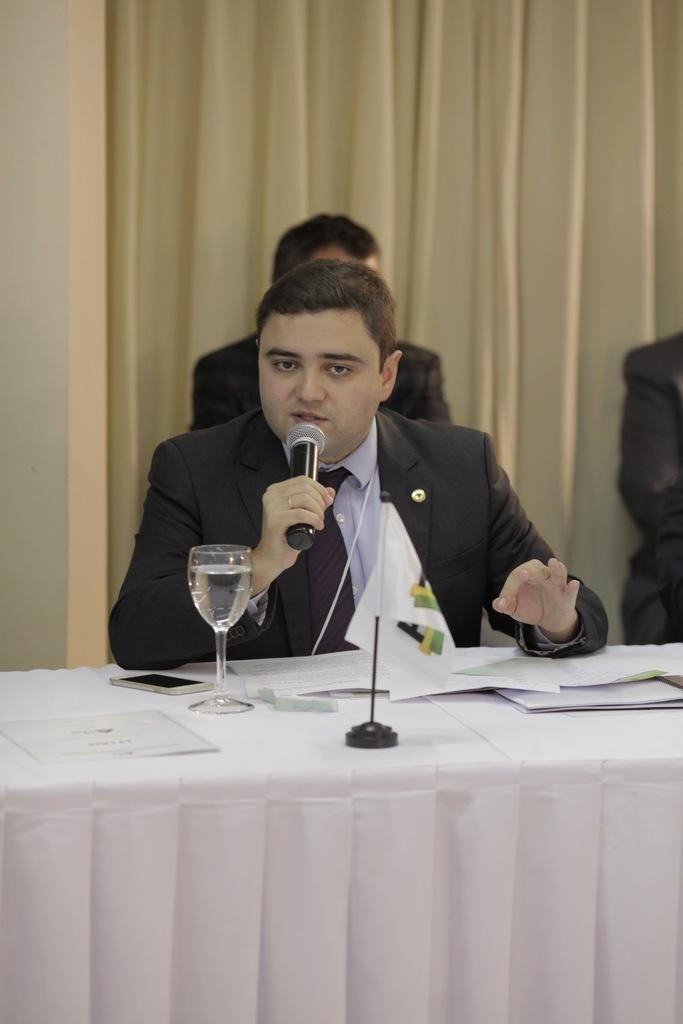Who is the main subject in the image? There is a man in the image. What is the man holding in the image? The man is holding a microphone. Where is the man sitting in the image? The man is sitting at a table. What type of goat can be seen in the image? There is no goat present in the image. How many beads are on the man's necklace in the image? The man is not wearing a necklace in the image, so there are no beads to count. 